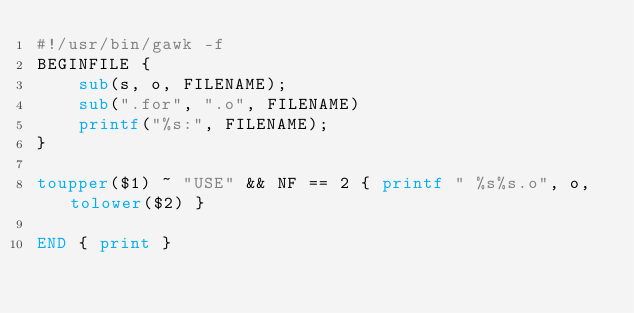Convert code to text. <code><loc_0><loc_0><loc_500><loc_500><_Awk_>#!/usr/bin/gawk -f
BEGINFILE {
    sub(s, o, FILENAME);
    sub(".for", ".o", FILENAME)
    printf("%s:", FILENAME);
}

toupper($1) ~ "USE" && NF == 2 { printf " %s%s.o", o, tolower($2) }

END { print }

</code> 